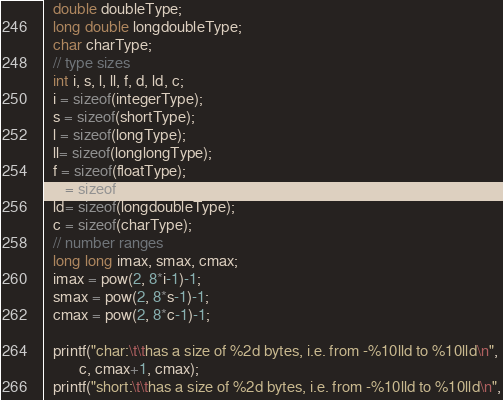<code> <loc_0><loc_0><loc_500><loc_500><_C_>  double doubleType;
  long double longdoubleType;
  char charType;
  // type sizes
  int i, s, l, ll, f, d, ld, c;
  i = sizeof(integerType);
  s = sizeof(shortType);
  l = sizeof(longType);
  ll= sizeof(longlongType);
  f = sizeof(floatType);
  d = sizeof(doubleType);
  ld= sizeof(longdoubleType);
  c = sizeof(charType);
  // number ranges
  long long imax, smax, cmax;
  imax = pow(2, 8*i-1)-1;
  smax = pow(2, 8*s-1)-1;
  cmax = pow(2, 8*c-1)-1;
  
  printf("char:\t\thas a size of %2d bytes, i.e. from -%10lld to %10lld\n",
         c, cmax+1, cmax);
  printf("short:\t\thas a size of %2d bytes, i.e. from -%10lld to %10lld\n",</code> 